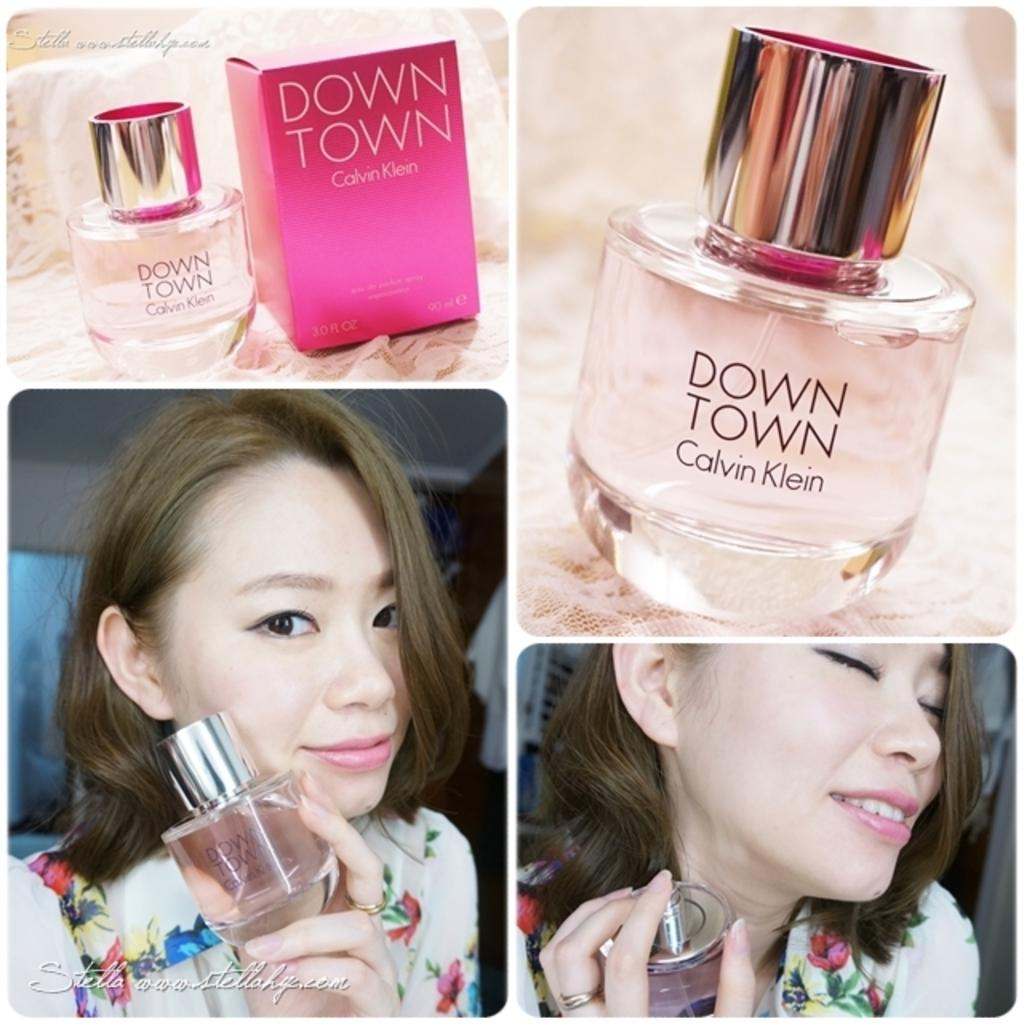<image>
Present a compact description of the photo's key features. A small bottle of perfume bears the name Down Town and it's by Calvin Klein. 